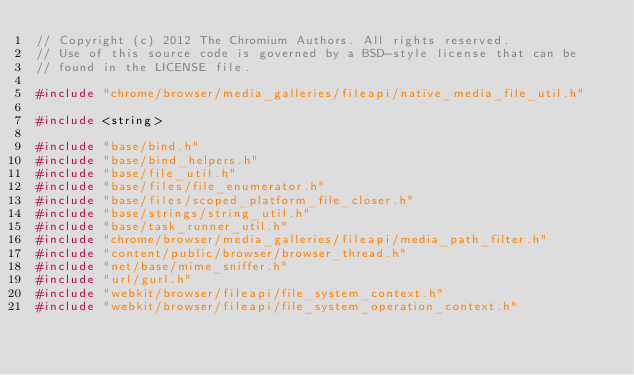<code> <loc_0><loc_0><loc_500><loc_500><_C++_>// Copyright (c) 2012 The Chromium Authors. All rights reserved.
// Use of this source code is governed by a BSD-style license that can be
// found in the LICENSE file.

#include "chrome/browser/media_galleries/fileapi/native_media_file_util.h"

#include <string>

#include "base/bind.h"
#include "base/bind_helpers.h"
#include "base/file_util.h"
#include "base/files/file_enumerator.h"
#include "base/files/scoped_platform_file_closer.h"
#include "base/strings/string_util.h"
#include "base/task_runner_util.h"
#include "chrome/browser/media_galleries/fileapi/media_path_filter.h"
#include "content/public/browser/browser_thread.h"
#include "net/base/mime_sniffer.h"
#include "url/gurl.h"
#include "webkit/browser/fileapi/file_system_context.h"
#include "webkit/browser/fileapi/file_system_operation_context.h"</code> 